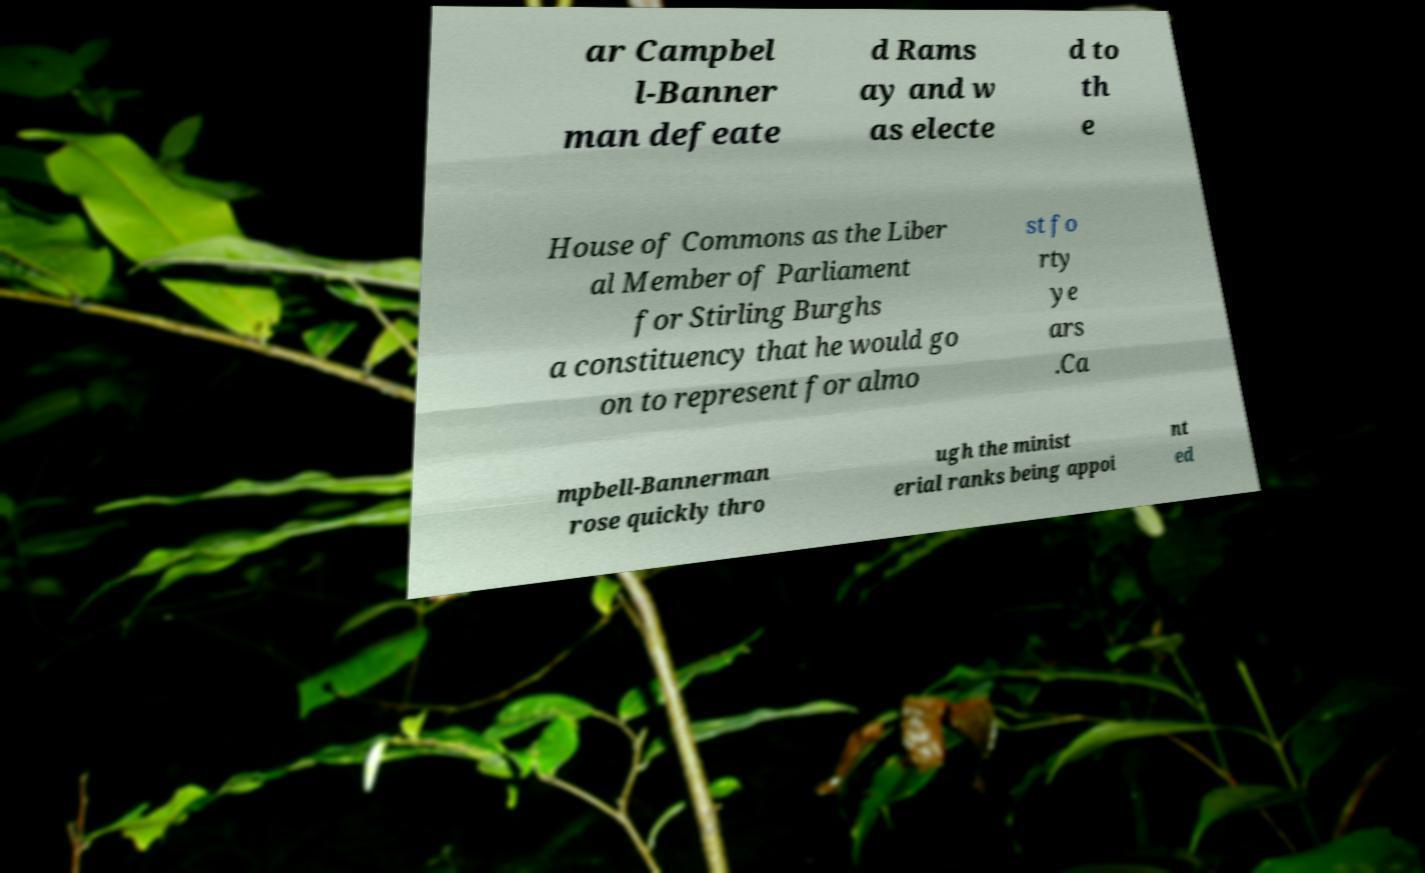Could you extract and type out the text from this image? ar Campbel l-Banner man defeate d Rams ay and w as electe d to th e House of Commons as the Liber al Member of Parliament for Stirling Burghs a constituency that he would go on to represent for almo st fo rty ye ars .Ca mpbell-Bannerman rose quickly thro ugh the minist erial ranks being appoi nt ed 